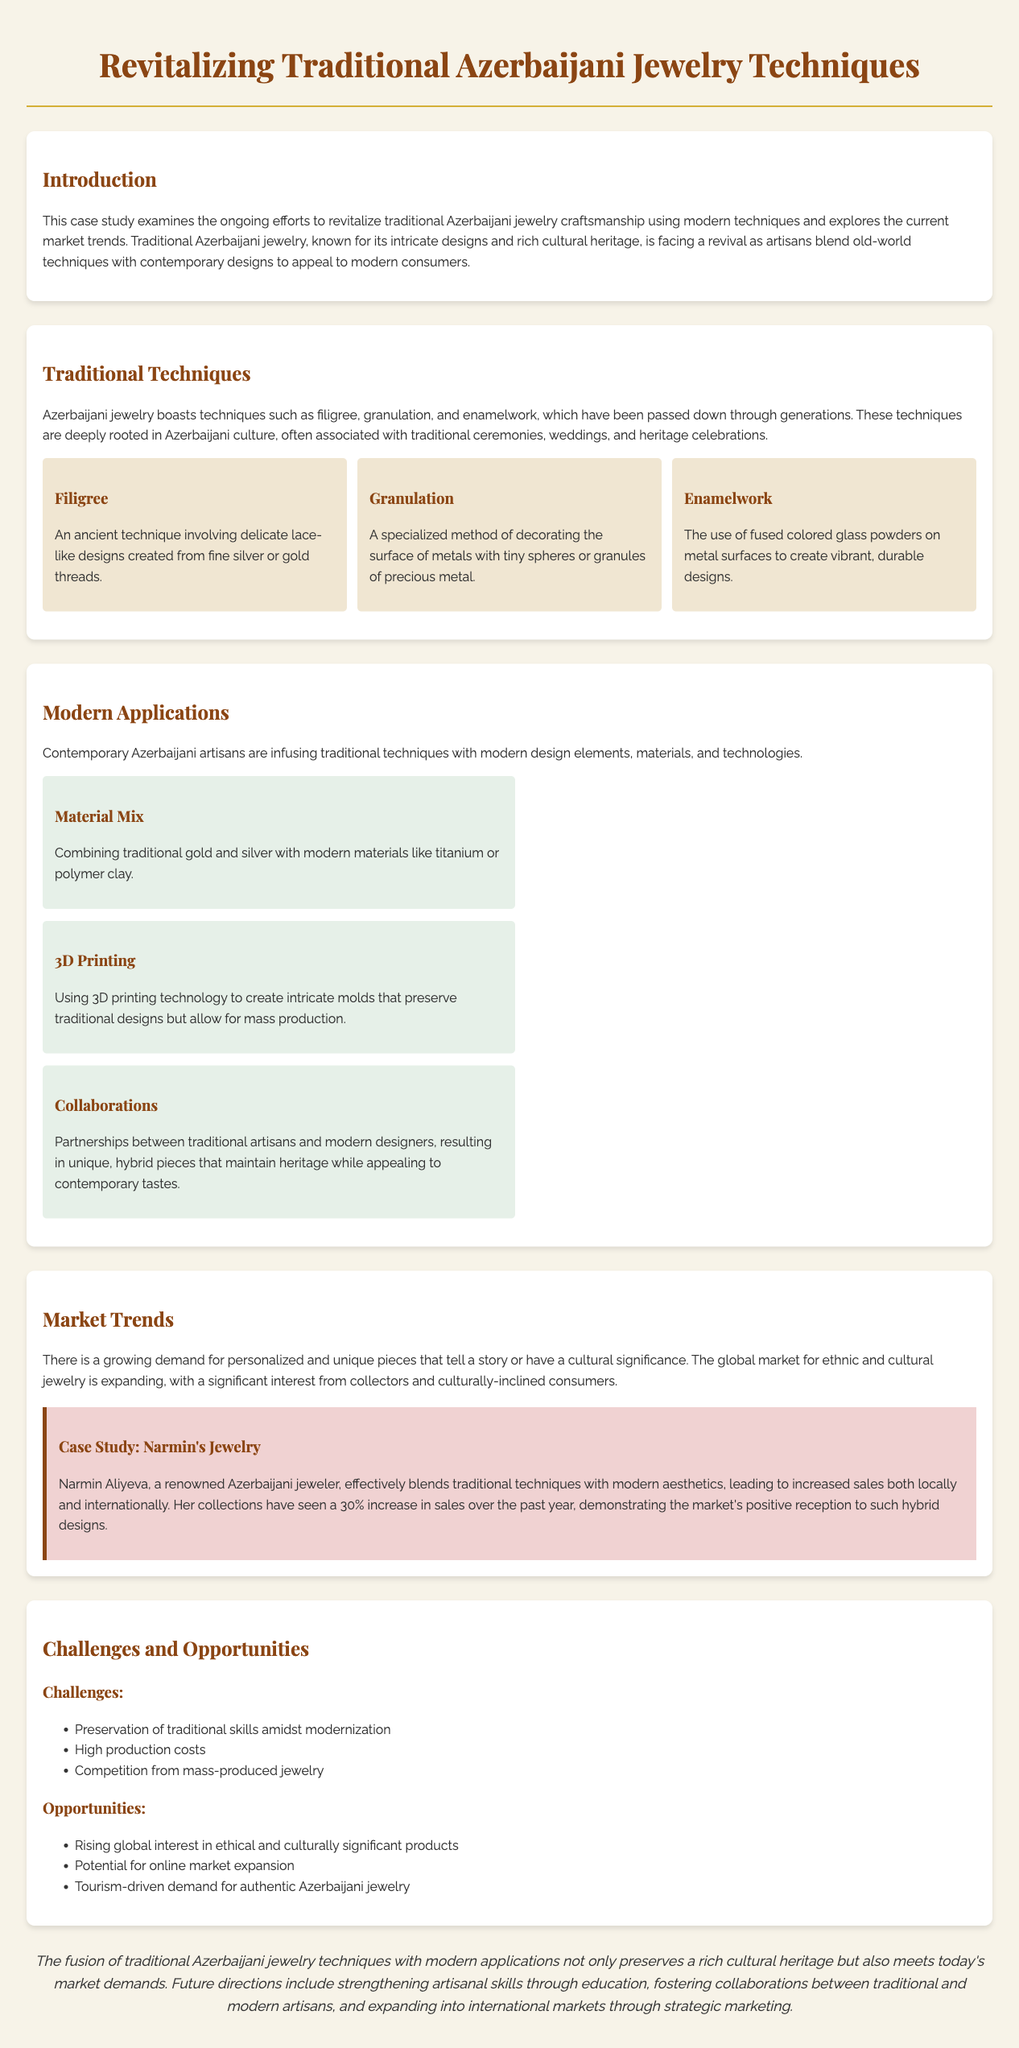what is the main focus of the case study? The case study examines the revitalization of traditional Azerbaijani jewelry craftsmanship using modern techniques and explores current market trends.
Answer: revitalization of traditional Azerbaijani jewelry craftsmanship which traditional technique involves delicate lace-like designs? The lace-like designs created from fine silver or gold threads refer to the filigree technique.
Answer: filigree what percentage increase in sales did Narmin's Jewelry experience? Narmin's Jewelry collections saw a 30% increase in sales over the past year, showcasing market reception.
Answer: 30% what is one modern application that uses 3D printing? The use of 3D printing technology to create intricate molds while preserving traditional designs is highlighted.
Answer: intricate molds which challenge is mentioned regarding traditional jewelry production? One challenge outlined is the preservation of traditional skills amidst modernization in jewelry production.
Answer: preservation of traditional skills what is one opportunity for Azerbaijani jewelry mentioned in the document? Rising global interest in ethical and culturally significant products provides an opportunity for artisans.
Answer: ethical and culturally significant products who is a renowned Azerbaijani jeweler mentioned in the case study? The case study mentions Narmin Aliyeva as the renowned Azerbaijani jeweler successfully blending traditional techniques with modern aesthetics.
Answer: Narmin Aliyeva what is a challenge related to competition in the jewelry market? Competition from mass-produced jewelry poses a challenge, affecting traditional artisans.
Answer: mass-produced jewelry how does the case study propose to strengthen artisanal skills? The document suggests strengthening artisanal skills through education as a future direction for the jewelry sector.
Answer: education 